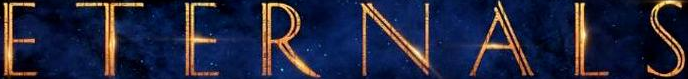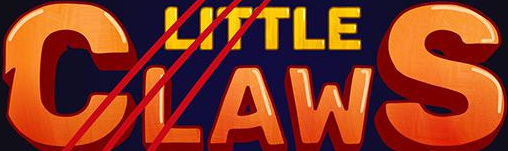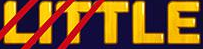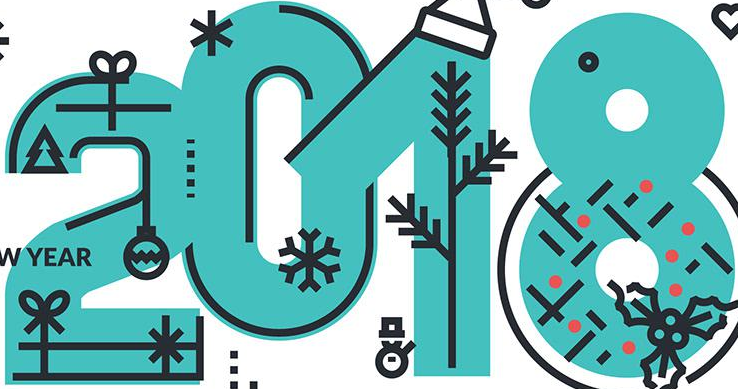What text is displayed in these images sequentially, separated by a semicolon? ETERNALS; CLAWS; LITTLE; 2018 